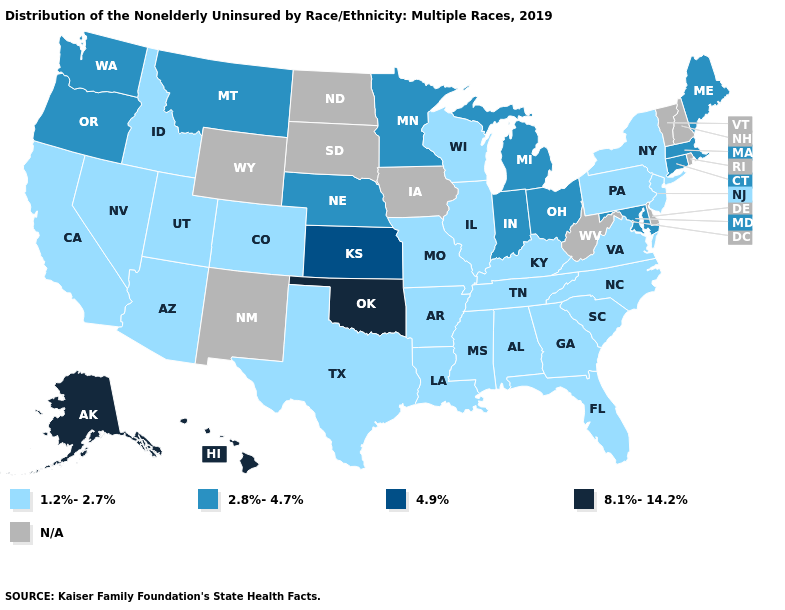What is the highest value in states that border Ohio?
Concise answer only. 2.8%-4.7%. Does the first symbol in the legend represent the smallest category?
Concise answer only. Yes. Name the states that have a value in the range 1.2%-2.7%?
Keep it brief. Alabama, Arizona, Arkansas, California, Colorado, Florida, Georgia, Idaho, Illinois, Kentucky, Louisiana, Mississippi, Missouri, Nevada, New Jersey, New York, North Carolina, Pennsylvania, South Carolina, Tennessee, Texas, Utah, Virginia, Wisconsin. What is the value of Kansas?
Give a very brief answer. 4.9%. Does Oklahoma have the highest value in the USA?
Short answer required. Yes. Name the states that have a value in the range 2.8%-4.7%?
Write a very short answer. Connecticut, Indiana, Maine, Maryland, Massachusetts, Michigan, Minnesota, Montana, Nebraska, Ohio, Oregon, Washington. Does Illinois have the lowest value in the USA?
Be succinct. Yes. How many symbols are there in the legend?
Short answer required. 5. Name the states that have a value in the range 1.2%-2.7%?
Give a very brief answer. Alabama, Arizona, Arkansas, California, Colorado, Florida, Georgia, Idaho, Illinois, Kentucky, Louisiana, Mississippi, Missouri, Nevada, New Jersey, New York, North Carolina, Pennsylvania, South Carolina, Tennessee, Texas, Utah, Virginia, Wisconsin. Among the states that border Utah , which have the highest value?
Be succinct. Arizona, Colorado, Idaho, Nevada. What is the value of Rhode Island?
Be succinct. N/A. Name the states that have a value in the range 8.1%-14.2%?
Be succinct. Alaska, Hawaii, Oklahoma. What is the value of Nevada?
Concise answer only. 1.2%-2.7%. 